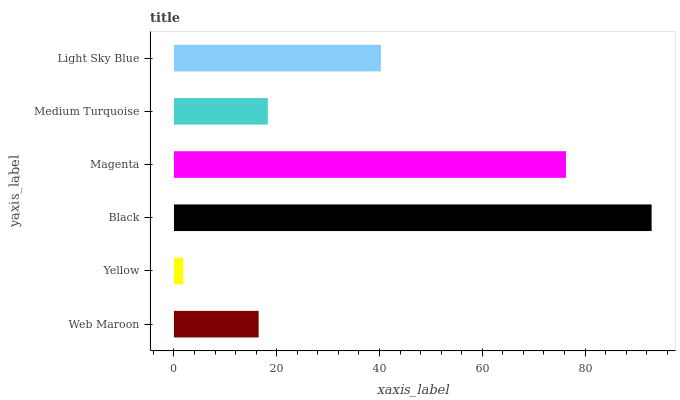Is Yellow the minimum?
Answer yes or no. Yes. Is Black the maximum?
Answer yes or no. Yes. Is Black the minimum?
Answer yes or no. No. Is Yellow the maximum?
Answer yes or no. No. Is Black greater than Yellow?
Answer yes or no. Yes. Is Yellow less than Black?
Answer yes or no. Yes. Is Yellow greater than Black?
Answer yes or no. No. Is Black less than Yellow?
Answer yes or no. No. Is Light Sky Blue the high median?
Answer yes or no. Yes. Is Medium Turquoise the low median?
Answer yes or no. Yes. Is Medium Turquoise the high median?
Answer yes or no. No. Is Magenta the low median?
Answer yes or no. No. 